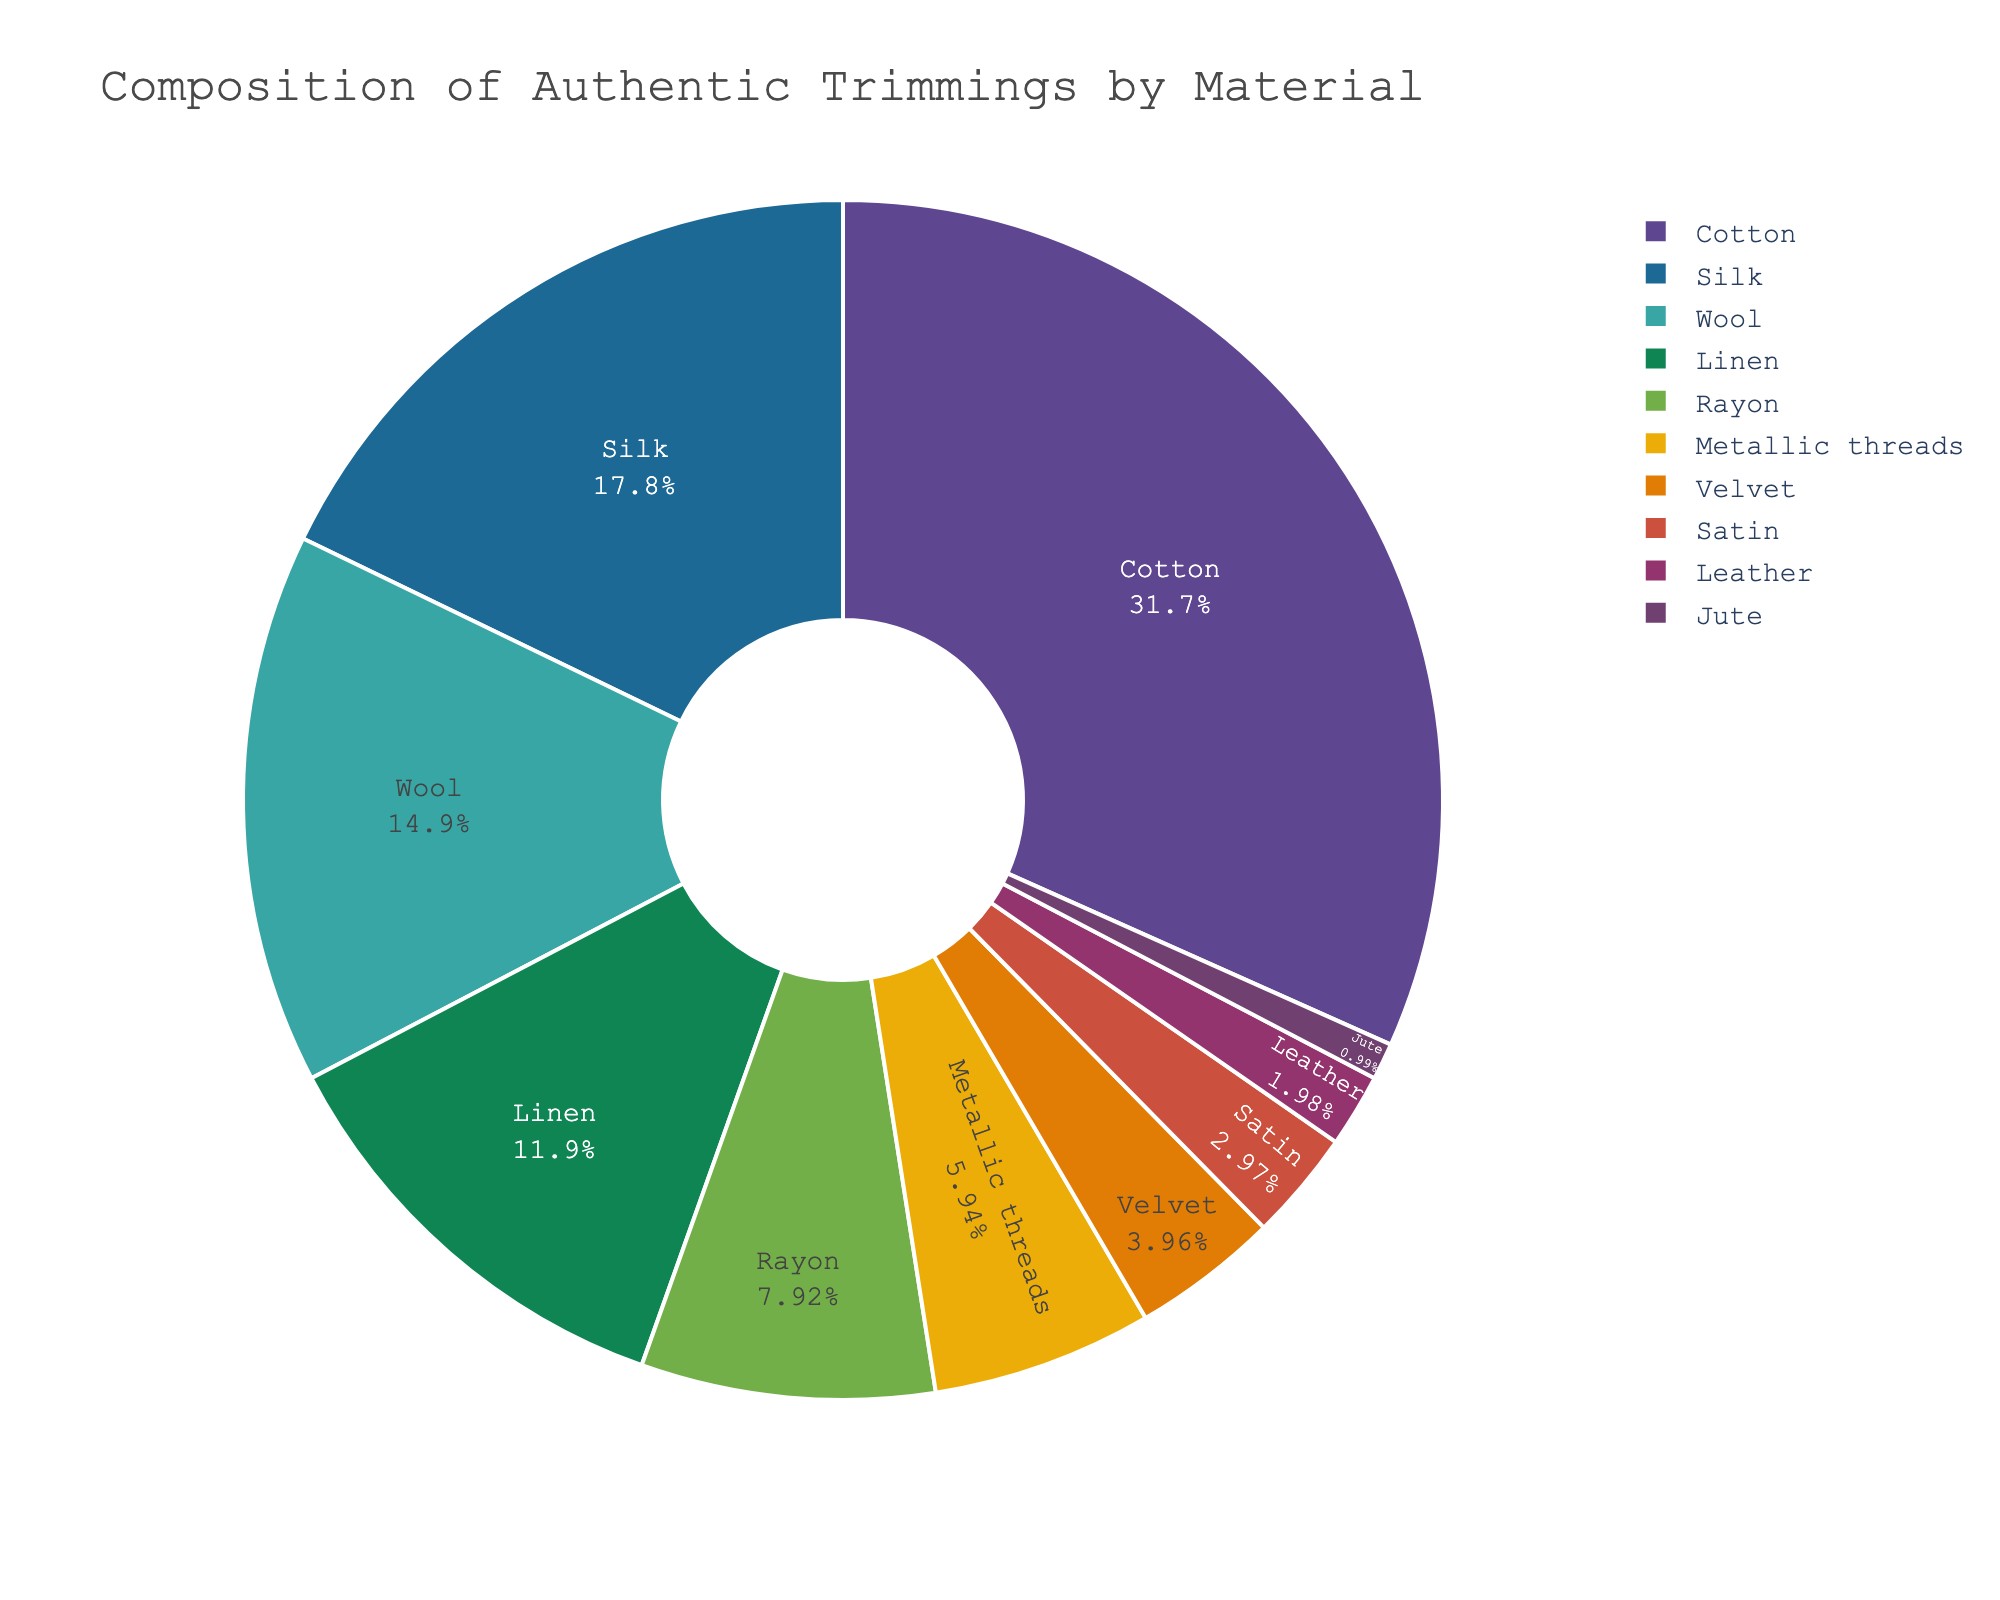What is the material with the highest percentage? The chart shows various materials, and by looking at the slices, the largest slice represents cotton.
Answer: Cotton Which material has a smaller percentage, Linen or Rayon? By comparing the slices representing Linen and Rayon, it's clear that Linen has a larger percentage slice than Rayon.
Answer: Rayon What is the combined percentage of Silk and Wool? Silk makes up 18% and Wool makes up 15%. By adding these two percentages, 18% + 15% = 33%.
Answer: 33% Which material has the smallest percentage? The smallest slice on the pie chart corresponds to Jute.
Answer: Jute How much larger is the percentage of Cotton compared to Satin? Cotton has 32% and Satin has 3%, so the difference is 32% - 3% = 29%.
Answer: 29% Which material has a higher percentage, Metallic threads or Velvet? By comparing the slices for Metallic threads and Velvet, Metallic threads has a larger percentage.
Answer: Metallic threads What is the total percentage for all natural materials (Cotton, Silk, Wool, Linen, Velvet)? Summing the percentages for Cotton (32%), Silk (18%), Wool (15%), Linen (12%), and Velvet (4%): 32% + 18% + 15% + 12% + 4% = 81%.
Answer: 81% What percentage does Rayon hold among all the synthetic materials (Rayon, Metallic threads, Satin)? The total percentage for synthetic materials is Rayon (8%) + Metallic threads (6%) + Satin (3%) = 17%. Since Rayon is 8%, its percentage among synthetics is (8/17) * 100 ≈ 47.06%.
Answer: 47.06% Which materials have a percentage lower than 10%? By examining the pie chart, Rayon (8%), Metallic threads (6%), Velvet (4%), Satin (3%), Leather (2%), and Jute (1%) all have percentages below 10%.
Answer: Rayon, Metallic threads, Velvet, Satin, Leather, Jute 